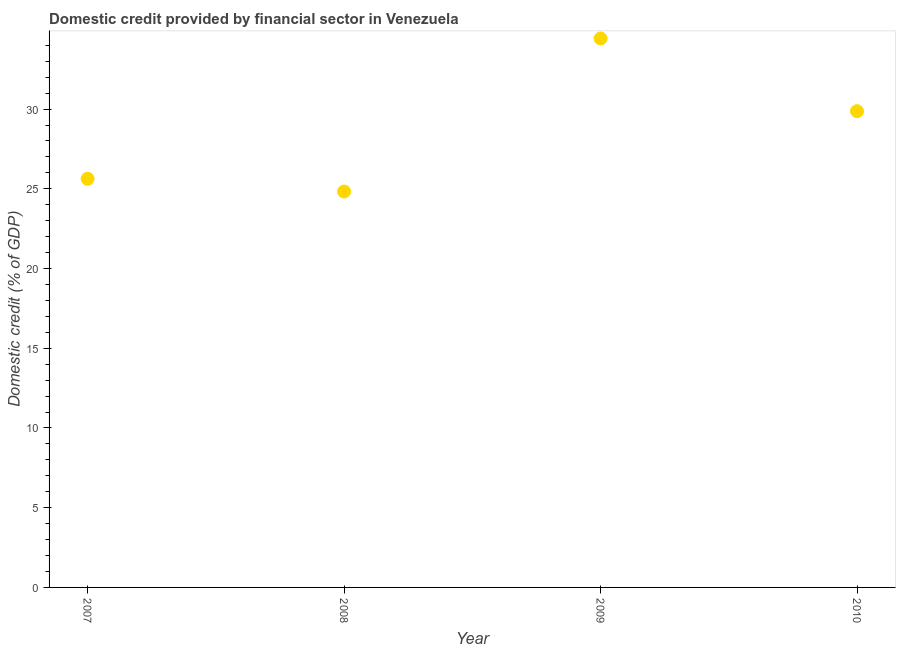What is the domestic credit provided by financial sector in 2009?
Provide a short and direct response. 34.43. Across all years, what is the maximum domestic credit provided by financial sector?
Offer a terse response. 34.43. Across all years, what is the minimum domestic credit provided by financial sector?
Provide a succinct answer. 24.83. In which year was the domestic credit provided by financial sector maximum?
Your answer should be very brief. 2009. What is the sum of the domestic credit provided by financial sector?
Keep it short and to the point. 114.76. What is the difference between the domestic credit provided by financial sector in 2009 and 2010?
Your answer should be very brief. 4.56. What is the average domestic credit provided by financial sector per year?
Your answer should be very brief. 28.69. What is the median domestic credit provided by financial sector?
Your answer should be compact. 27.75. Do a majority of the years between 2009 and 2007 (inclusive) have domestic credit provided by financial sector greater than 16 %?
Offer a terse response. No. What is the ratio of the domestic credit provided by financial sector in 2007 to that in 2009?
Offer a very short reply. 0.74. What is the difference between the highest and the second highest domestic credit provided by financial sector?
Make the answer very short. 4.56. What is the difference between the highest and the lowest domestic credit provided by financial sector?
Give a very brief answer. 9.6. Does the domestic credit provided by financial sector monotonically increase over the years?
Provide a short and direct response. No. Are the values on the major ticks of Y-axis written in scientific E-notation?
Provide a short and direct response. No. Does the graph contain grids?
Provide a short and direct response. No. What is the title of the graph?
Your answer should be compact. Domestic credit provided by financial sector in Venezuela. What is the label or title of the Y-axis?
Provide a succinct answer. Domestic credit (% of GDP). What is the Domestic credit (% of GDP) in 2007?
Provide a short and direct response. 25.63. What is the Domestic credit (% of GDP) in 2008?
Offer a very short reply. 24.83. What is the Domestic credit (% of GDP) in 2009?
Provide a succinct answer. 34.43. What is the Domestic credit (% of GDP) in 2010?
Ensure brevity in your answer.  29.87. What is the difference between the Domestic credit (% of GDP) in 2007 and 2008?
Make the answer very short. 0.8. What is the difference between the Domestic credit (% of GDP) in 2007 and 2009?
Make the answer very short. -8.8. What is the difference between the Domestic credit (% of GDP) in 2007 and 2010?
Provide a short and direct response. -4.24. What is the difference between the Domestic credit (% of GDP) in 2008 and 2009?
Your response must be concise. -9.6. What is the difference between the Domestic credit (% of GDP) in 2008 and 2010?
Offer a terse response. -5.04. What is the difference between the Domestic credit (% of GDP) in 2009 and 2010?
Offer a terse response. 4.56. What is the ratio of the Domestic credit (% of GDP) in 2007 to that in 2008?
Make the answer very short. 1.03. What is the ratio of the Domestic credit (% of GDP) in 2007 to that in 2009?
Ensure brevity in your answer.  0.74. What is the ratio of the Domestic credit (% of GDP) in 2007 to that in 2010?
Keep it short and to the point. 0.86. What is the ratio of the Domestic credit (% of GDP) in 2008 to that in 2009?
Your response must be concise. 0.72. What is the ratio of the Domestic credit (% of GDP) in 2008 to that in 2010?
Offer a very short reply. 0.83. What is the ratio of the Domestic credit (% of GDP) in 2009 to that in 2010?
Your answer should be very brief. 1.15. 